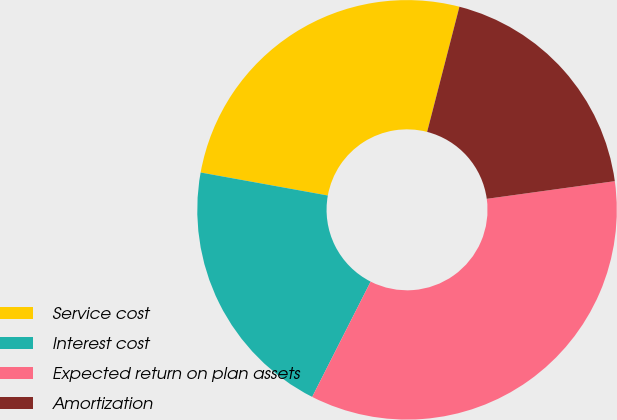Convert chart to OTSL. <chart><loc_0><loc_0><loc_500><loc_500><pie_chart><fcel>Service cost<fcel>Interest cost<fcel>Expected return on plan assets<fcel>Amortization<nl><fcel>26.17%<fcel>20.38%<fcel>34.65%<fcel>18.8%<nl></chart> 